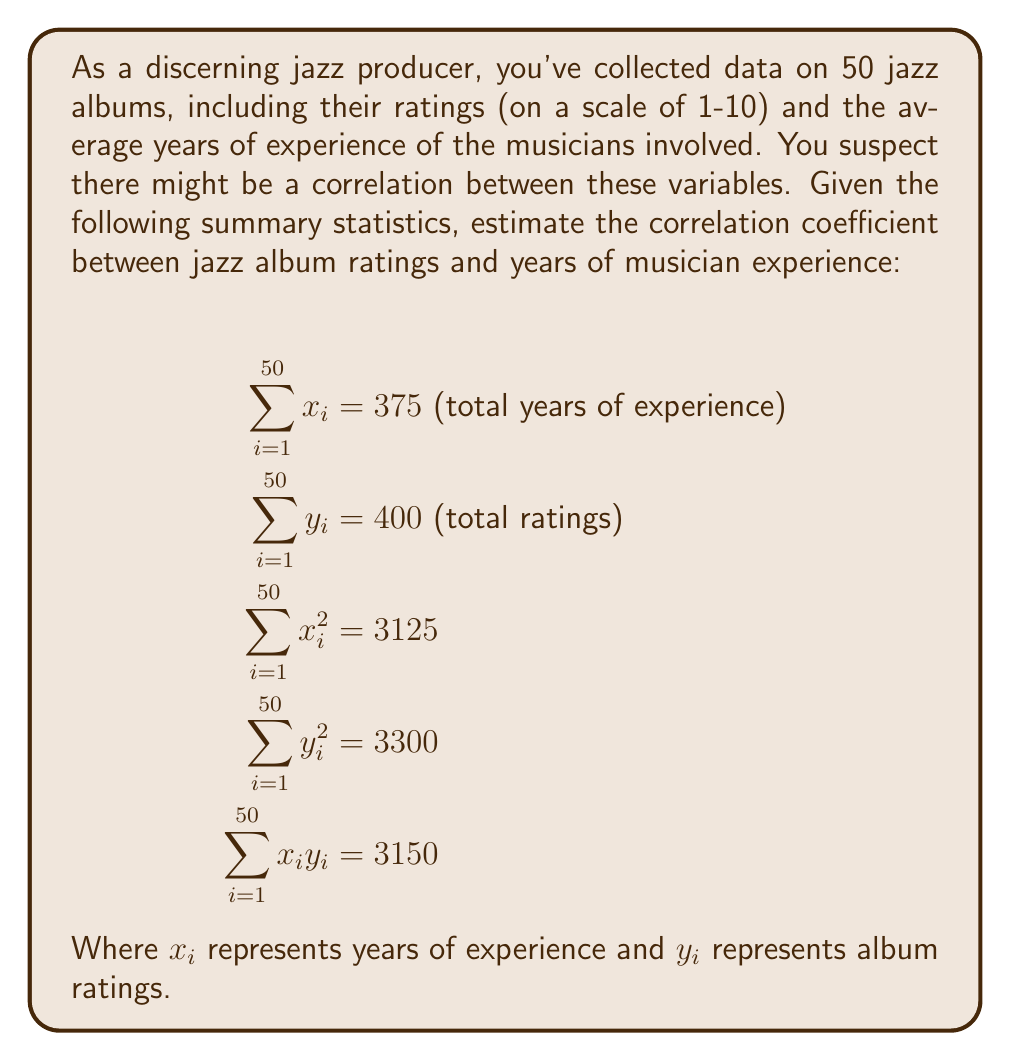Can you solve this math problem? To estimate the correlation coefficient, we'll use the Pearson correlation formula:

$$r = \frac{n\sum x_iy_i - (\sum x_i)(\sum y_i)}{\sqrt{[n\sum x_i^2 - (\sum x_i)^2][n\sum y_i^2 - (\sum y_i)^2]}}$$

Where $n$ is the number of data points (50 in this case).

Step 1: Calculate the numerator
$$n\sum x_iy_i - (\sum x_i)(\sum y_i) = 50(3150) - (375)(400) = 7500$$

Step 2: Calculate the first part of the denominator
$$n\sum x_i^2 - (\sum x_i)^2 = 50(3125) - (375)^2 = 15625$$

Step 3: Calculate the second part of the denominator
$$n\sum y_i^2 - (\sum y_i)^2 = 50(3300) - (400)^2 = 5000$$

Step 4: Multiply the results from steps 2 and 3
$$15625 \times 5000 = 78125000$$

Step 5: Take the square root of the result from step 4
$$\sqrt{78125000} = 8838.835$$

Step 6: Divide the result from step 1 by the result from step 5
$$r = \frac{7500}{8838.835} \approx 0.848$$

This indicates a strong positive correlation between jazz album ratings and years of musician experience.
Answer: $r \approx 0.848$ 